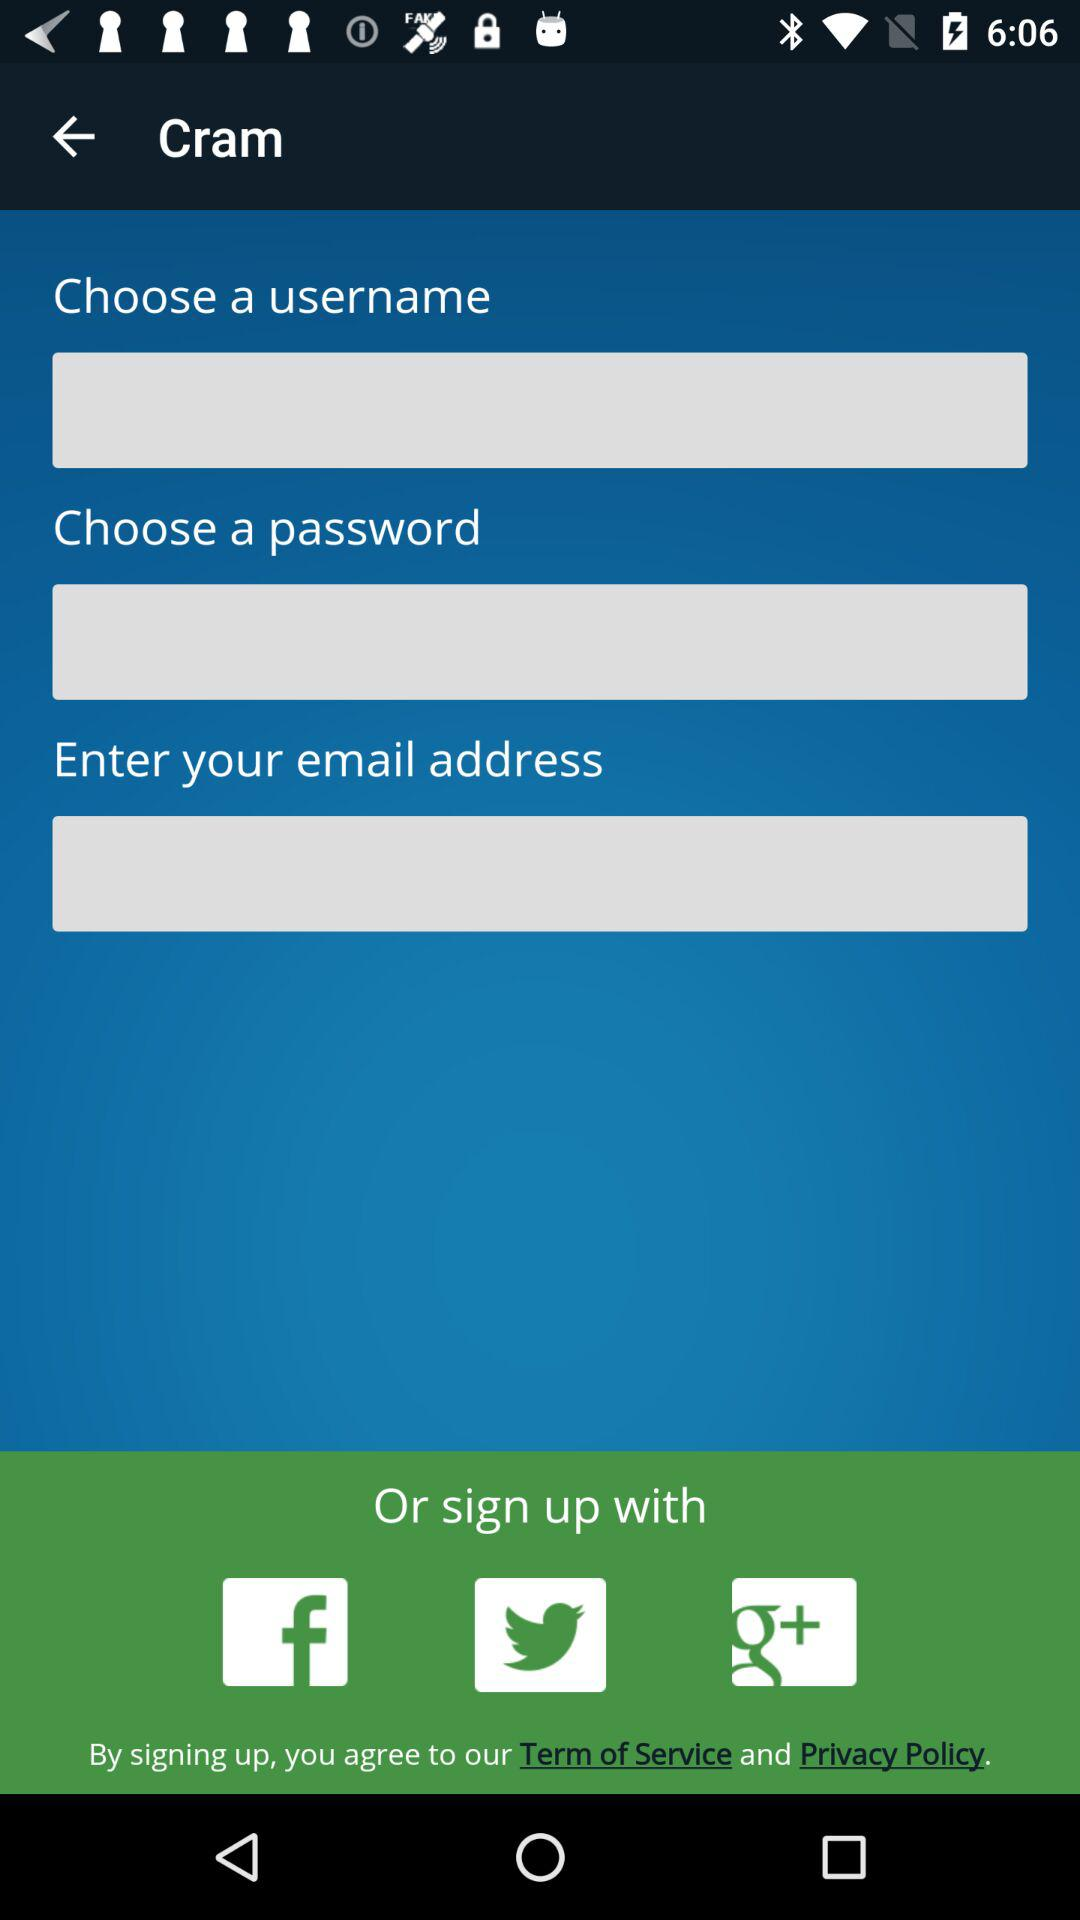Which account options are available for signing up? The available options for signing up are "Facebook", "Twitter" and "Google+". 